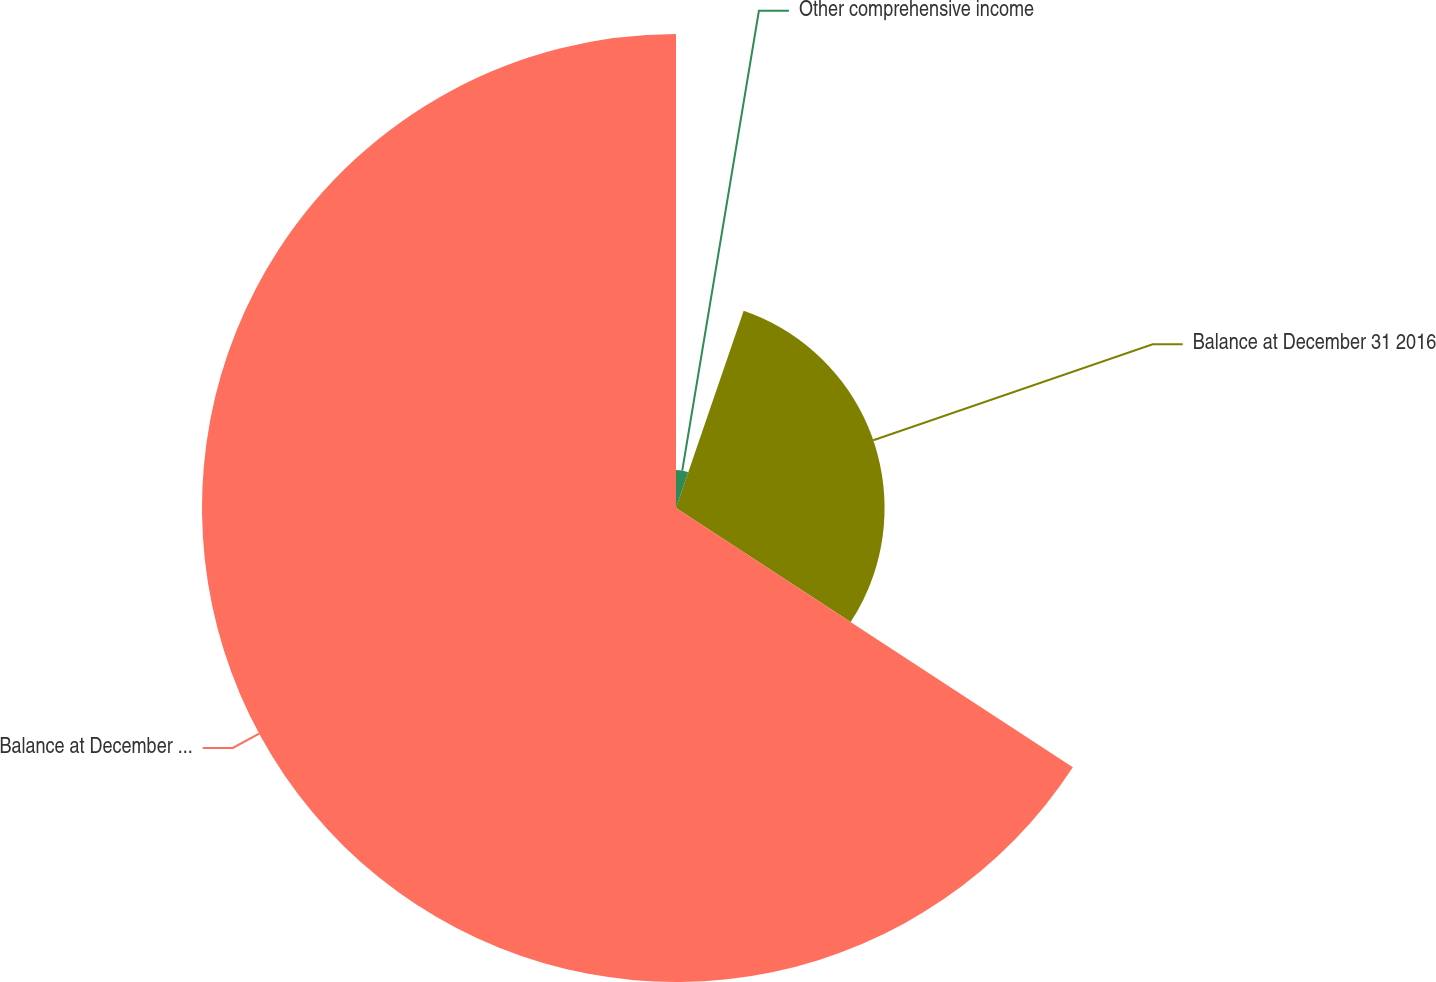<chart> <loc_0><loc_0><loc_500><loc_500><pie_chart><fcel>Other comprehensive income<fcel>Balance at December 31 2016<fcel>Balance at December 31 2017<nl><fcel>5.26%<fcel>28.95%<fcel>65.79%<nl></chart> 